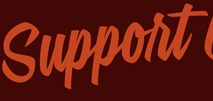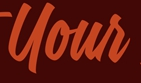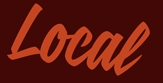What text is displayed in these images sequentially, separated by a semicolon? Support; Your; Local 